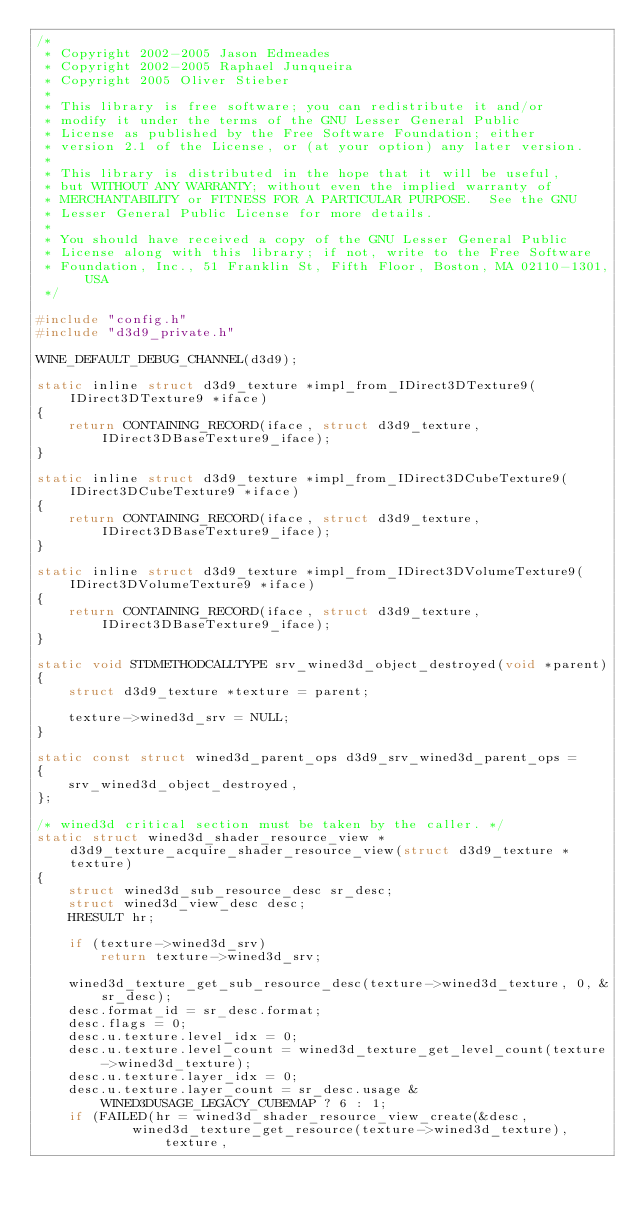<code> <loc_0><loc_0><loc_500><loc_500><_C_>/*
 * Copyright 2002-2005 Jason Edmeades
 * Copyright 2002-2005 Raphael Junqueira
 * Copyright 2005 Oliver Stieber
 *
 * This library is free software; you can redistribute it and/or
 * modify it under the terms of the GNU Lesser General Public
 * License as published by the Free Software Foundation; either
 * version 2.1 of the License, or (at your option) any later version.
 *
 * This library is distributed in the hope that it will be useful,
 * but WITHOUT ANY WARRANTY; without even the implied warranty of
 * MERCHANTABILITY or FITNESS FOR A PARTICULAR PURPOSE.  See the GNU
 * Lesser General Public License for more details.
 *
 * You should have received a copy of the GNU Lesser General Public
 * License along with this library; if not, write to the Free Software
 * Foundation, Inc., 51 Franklin St, Fifth Floor, Boston, MA 02110-1301, USA
 */

#include "config.h"
#include "d3d9_private.h"

WINE_DEFAULT_DEBUG_CHANNEL(d3d9);

static inline struct d3d9_texture *impl_from_IDirect3DTexture9(IDirect3DTexture9 *iface)
{
    return CONTAINING_RECORD(iface, struct d3d9_texture, IDirect3DBaseTexture9_iface);
}

static inline struct d3d9_texture *impl_from_IDirect3DCubeTexture9(IDirect3DCubeTexture9 *iface)
{
    return CONTAINING_RECORD(iface, struct d3d9_texture, IDirect3DBaseTexture9_iface);
}

static inline struct d3d9_texture *impl_from_IDirect3DVolumeTexture9(IDirect3DVolumeTexture9 *iface)
{
    return CONTAINING_RECORD(iface, struct d3d9_texture, IDirect3DBaseTexture9_iface);
}

static void STDMETHODCALLTYPE srv_wined3d_object_destroyed(void *parent)
{
    struct d3d9_texture *texture = parent;

    texture->wined3d_srv = NULL;
}

static const struct wined3d_parent_ops d3d9_srv_wined3d_parent_ops =
{
    srv_wined3d_object_destroyed,
};

/* wined3d critical section must be taken by the caller. */
static struct wined3d_shader_resource_view *d3d9_texture_acquire_shader_resource_view(struct d3d9_texture *texture)
{
    struct wined3d_sub_resource_desc sr_desc;
    struct wined3d_view_desc desc;
    HRESULT hr;

    if (texture->wined3d_srv)
        return texture->wined3d_srv;

    wined3d_texture_get_sub_resource_desc(texture->wined3d_texture, 0, &sr_desc);
    desc.format_id = sr_desc.format;
    desc.flags = 0;
    desc.u.texture.level_idx = 0;
    desc.u.texture.level_count = wined3d_texture_get_level_count(texture->wined3d_texture);
    desc.u.texture.layer_idx = 0;
    desc.u.texture.layer_count = sr_desc.usage & WINED3DUSAGE_LEGACY_CUBEMAP ? 6 : 1;
    if (FAILED(hr = wined3d_shader_resource_view_create(&desc,
            wined3d_texture_get_resource(texture->wined3d_texture), texture,</code> 